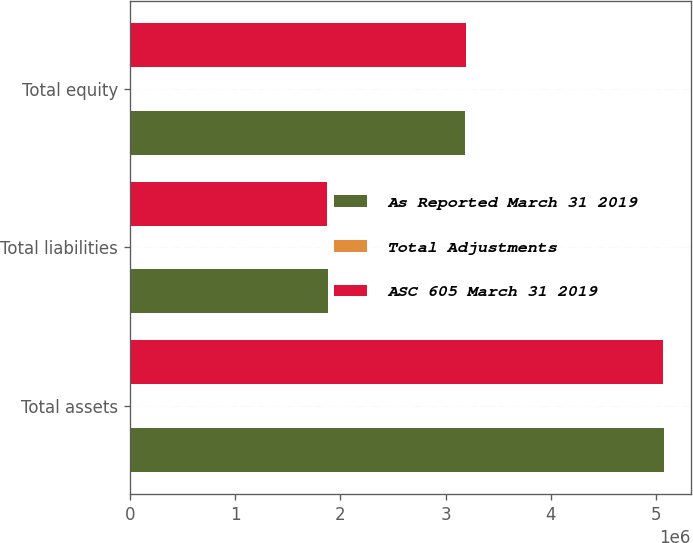Convert chart to OTSL. <chart><loc_0><loc_0><loc_500><loc_500><stacked_bar_chart><ecel><fcel>Total assets<fcel>Total liabilities<fcel>Total equity<nl><fcel>As Reported March 31 2019<fcel>5.07307e+06<fcel>1.88727e+06<fcel>3.1858e+06<nl><fcel>Total Adjustments<fcel>8429<fcel>14448<fcel>6019<nl><fcel>ASC 605 March 31 2019<fcel>5.06464e+06<fcel>1.87282e+06<fcel>3.19182e+06<nl></chart> 